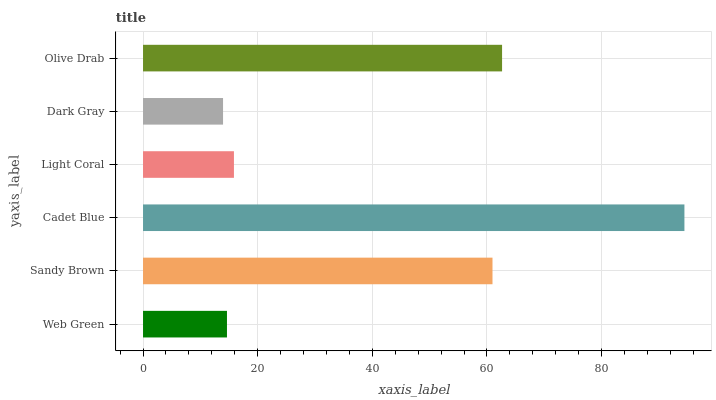Is Dark Gray the minimum?
Answer yes or no. Yes. Is Cadet Blue the maximum?
Answer yes or no. Yes. Is Sandy Brown the minimum?
Answer yes or no. No. Is Sandy Brown the maximum?
Answer yes or no. No. Is Sandy Brown greater than Web Green?
Answer yes or no. Yes. Is Web Green less than Sandy Brown?
Answer yes or no. Yes. Is Web Green greater than Sandy Brown?
Answer yes or no. No. Is Sandy Brown less than Web Green?
Answer yes or no. No. Is Sandy Brown the high median?
Answer yes or no. Yes. Is Light Coral the low median?
Answer yes or no. Yes. Is Olive Drab the high median?
Answer yes or no. No. Is Dark Gray the low median?
Answer yes or no. No. 